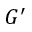Convert formula to latex. <formula><loc_0><loc_0><loc_500><loc_500>G ^ { \prime }</formula> 